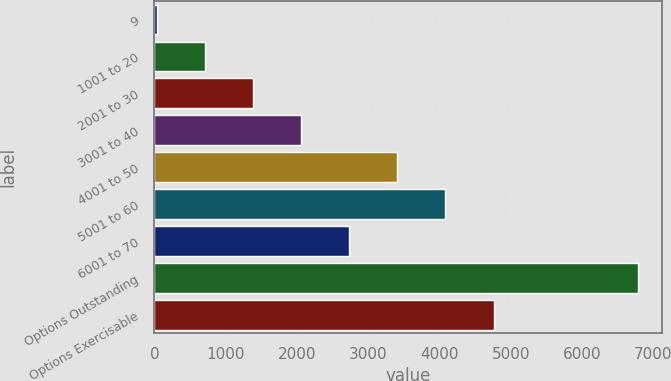Convert chart to OTSL. <chart><loc_0><loc_0><loc_500><loc_500><bar_chart><fcel>9<fcel>1001 to 20<fcel>2001 to 30<fcel>3001 to 40<fcel>4001 to 50<fcel>5001 to 60<fcel>6001 to 70<fcel>Options Outstanding<fcel>Options Exercisable<nl><fcel>31<fcel>706.4<fcel>1381.8<fcel>2057.2<fcel>3408<fcel>4083.4<fcel>2732.6<fcel>6785<fcel>4758.8<nl></chart> 